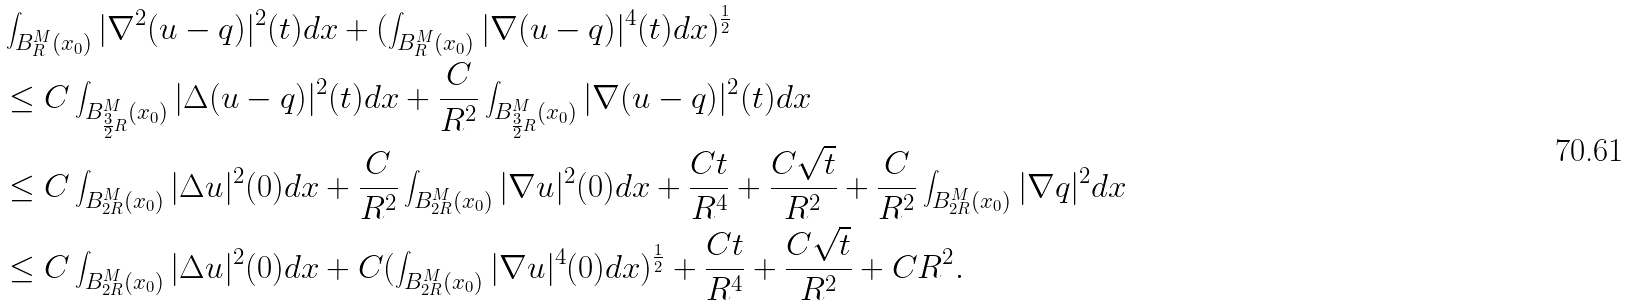<formula> <loc_0><loc_0><loc_500><loc_500>& \int _ { B ^ { M } _ { R } ( x _ { 0 } ) } | \nabla ^ { 2 } ( u - q ) | ^ { 2 } ( t ) d x + ( \int _ { B ^ { M } _ { R } ( x _ { 0 } ) } | \nabla ( u - q ) | ^ { 4 } ( t ) d x ) ^ { \frac { 1 } { 2 } } \\ & \leq C \int _ { B ^ { M } _ { \frac { 3 } { 2 } R } ( x _ { 0 } ) } | \Delta ( u - q ) | ^ { 2 } ( t ) d x + \frac { C } { R ^ { 2 } } \int _ { B ^ { M } _ { \frac { 3 } { 2 } R } ( x _ { 0 } ) } | \nabla ( u - q ) | ^ { 2 } ( t ) d x \\ & \leq C \int _ { B ^ { M } _ { 2 R } ( x _ { 0 } ) } | \Delta u | ^ { 2 } ( 0 ) d x + \frac { C } { R ^ { 2 } } \int _ { B ^ { M } _ { 2 R } ( x _ { 0 } ) } | \nabla u | ^ { 2 } ( 0 ) d x + \frac { C t } { R ^ { 4 } } + \frac { C \sqrt { t } } { R ^ { 2 } } + \frac { C } { R ^ { 2 } } \int _ { B ^ { M } _ { 2 R } ( x _ { 0 } ) } | \nabla q | ^ { 2 } d x \\ & \leq C \int _ { B ^ { M } _ { 2 R } ( x _ { 0 } ) } | \Delta u | ^ { 2 } ( 0 ) d x + C ( \int _ { B ^ { M } _ { 2 R } ( x _ { 0 } ) } | \nabla u | ^ { 4 } ( 0 ) d x ) ^ { \frac { 1 } { 2 } } + \frac { C t } { R ^ { 4 } } + \frac { C \sqrt { t } } { R ^ { 2 } } + C R ^ { 2 } .</formula> 